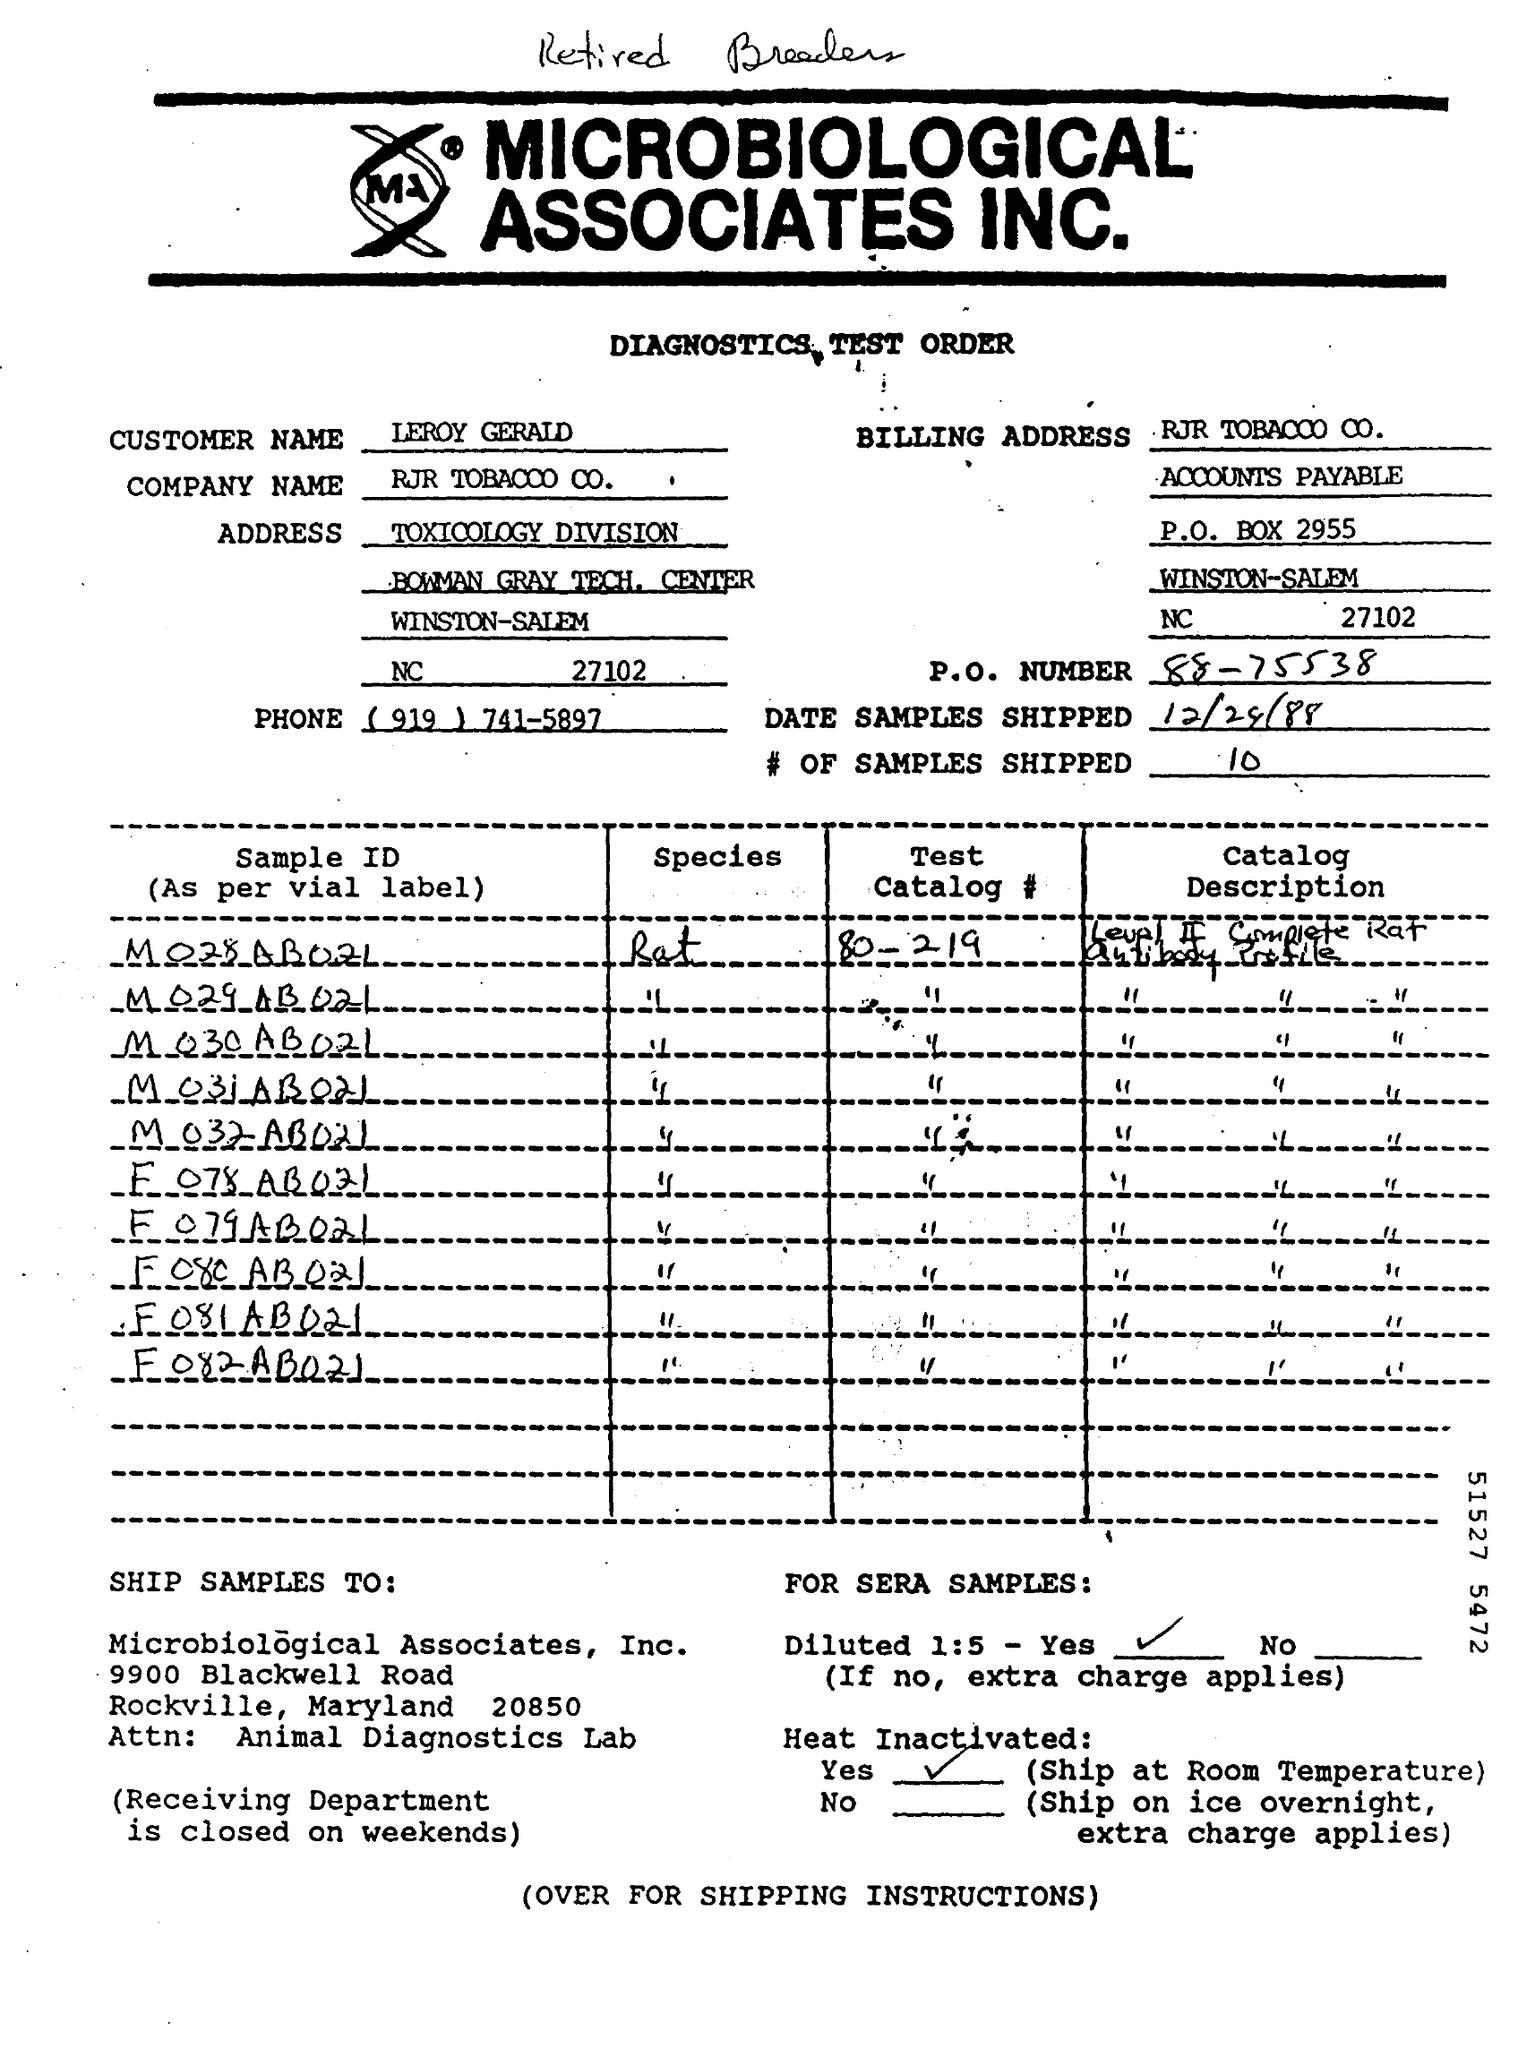What is the Company Name ?
Ensure brevity in your answer.  RJR TOBACOO CO. What is the Customer Name?
Your answer should be very brief. LEROY GERALD. What is the P.O Box Number ?
Your answer should be compact. 2955. What is the Phone Number ?
Provide a succinct answer. (919) 741-5897. What is the  P.O.Number ?
Make the answer very short. 88-75538. What is written in the Bottom of the Document ?
Make the answer very short. OVER FOR SHIPPING INSTRUCTIONS. How many number of samples shipped ?
Provide a short and direct response. 10. 